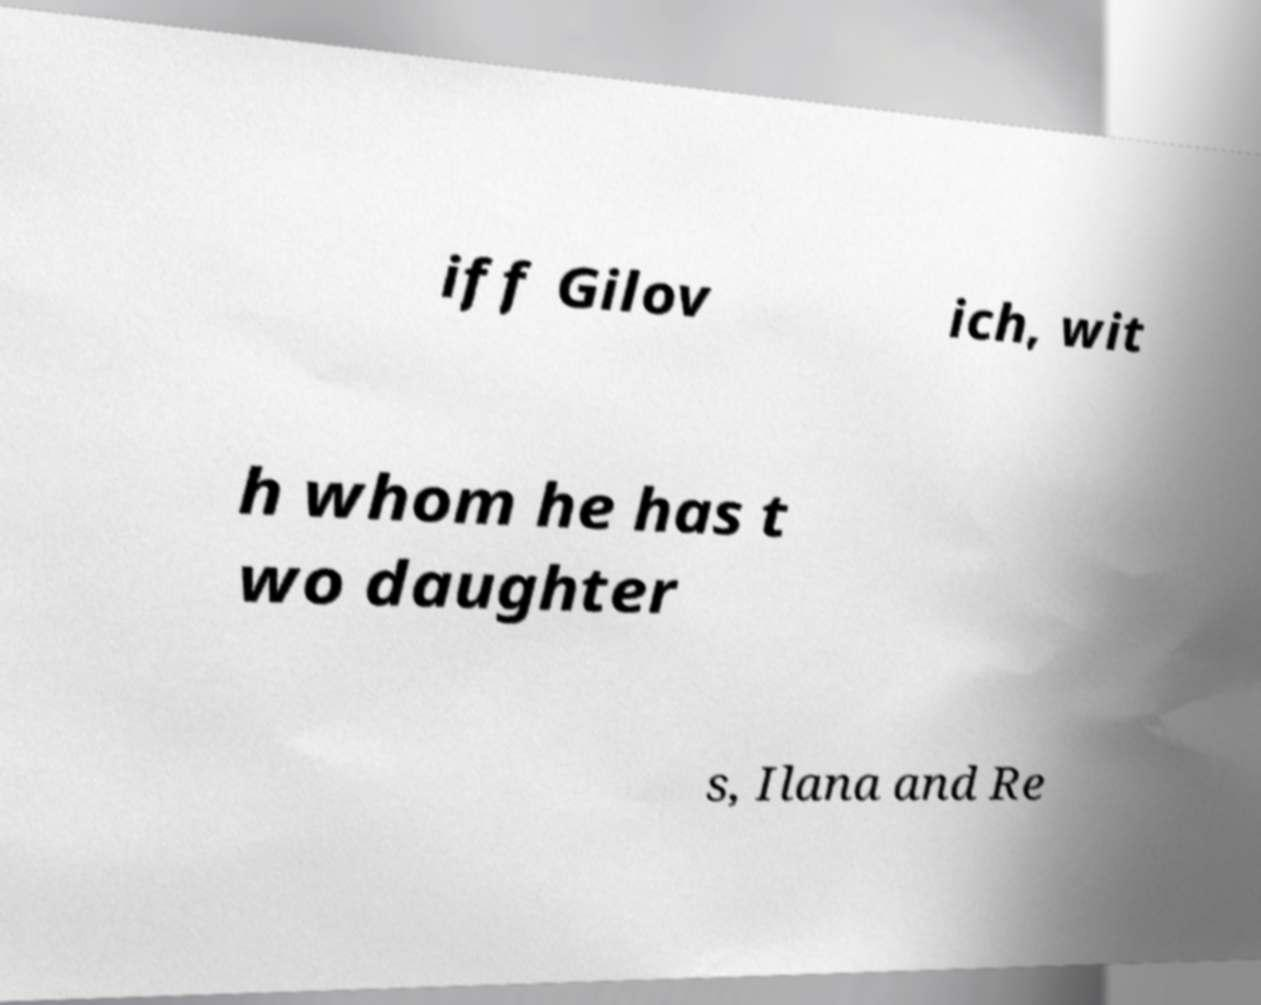I need the written content from this picture converted into text. Can you do that? iff Gilov ich, wit h whom he has t wo daughter s, Ilana and Re 